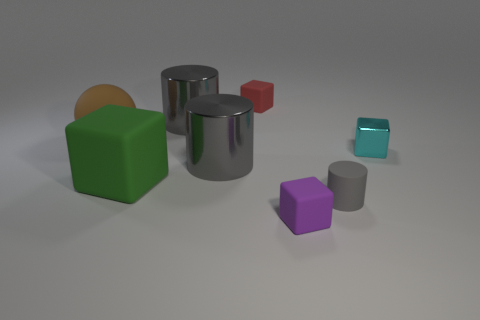Subtract all rubber cylinders. How many cylinders are left? 2 Subtract 2 cylinders. How many cylinders are left? 1 Subtract all green cubes. How many cubes are left? 3 Add 1 large matte spheres. How many objects exist? 9 Subtract 0 gray blocks. How many objects are left? 8 Subtract all cylinders. How many objects are left? 5 Subtract all green blocks. Subtract all purple cylinders. How many blocks are left? 3 Subtract all gray cylinders. How many red blocks are left? 1 Subtract all large cyan shiny balls. Subtract all purple cubes. How many objects are left? 7 Add 3 cyan blocks. How many cyan blocks are left? 4 